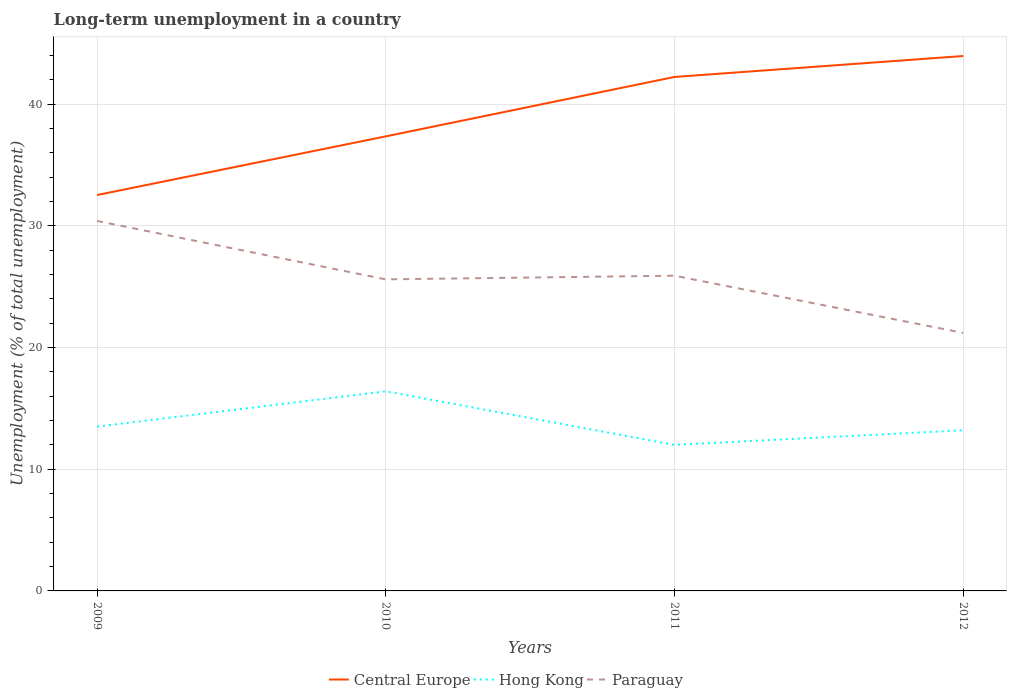Does the line corresponding to Paraguay intersect with the line corresponding to Hong Kong?
Provide a succinct answer. No. Is the number of lines equal to the number of legend labels?
Ensure brevity in your answer.  Yes. Across all years, what is the maximum percentage of long-term unemployed population in Central Europe?
Your answer should be compact. 32.53. In which year was the percentage of long-term unemployed population in Hong Kong maximum?
Keep it short and to the point. 2011. What is the total percentage of long-term unemployed population in Hong Kong in the graph?
Your answer should be compact. 3.2. What is the difference between the highest and the second highest percentage of long-term unemployed population in Central Europe?
Your answer should be compact. 11.42. Is the percentage of long-term unemployed population in Hong Kong strictly greater than the percentage of long-term unemployed population in Central Europe over the years?
Your answer should be compact. Yes. What is the difference between two consecutive major ticks on the Y-axis?
Offer a very short reply. 10. Are the values on the major ticks of Y-axis written in scientific E-notation?
Keep it short and to the point. No. Does the graph contain grids?
Give a very brief answer. Yes. What is the title of the graph?
Provide a succinct answer. Long-term unemployment in a country. What is the label or title of the X-axis?
Provide a succinct answer. Years. What is the label or title of the Y-axis?
Your answer should be compact. Unemployment (% of total unemployment). What is the Unemployment (% of total unemployment) of Central Europe in 2009?
Give a very brief answer. 32.53. What is the Unemployment (% of total unemployment) in Paraguay in 2009?
Your response must be concise. 30.4. What is the Unemployment (% of total unemployment) of Central Europe in 2010?
Offer a terse response. 37.35. What is the Unemployment (% of total unemployment) in Hong Kong in 2010?
Give a very brief answer. 16.4. What is the Unemployment (% of total unemployment) in Paraguay in 2010?
Your answer should be very brief. 25.6. What is the Unemployment (% of total unemployment) of Central Europe in 2011?
Your answer should be compact. 42.23. What is the Unemployment (% of total unemployment) of Paraguay in 2011?
Ensure brevity in your answer.  25.9. What is the Unemployment (% of total unemployment) in Central Europe in 2012?
Offer a terse response. 43.95. What is the Unemployment (% of total unemployment) of Hong Kong in 2012?
Offer a very short reply. 13.2. What is the Unemployment (% of total unemployment) in Paraguay in 2012?
Offer a very short reply. 21.2. Across all years, what is the maximum Unemployment (% of total unemployment) of Central Europe?
Your answer should be very brief. 43.95. Across all years, what is the maximum Unemployment (% of total unemployment) of Hong Kong?
Provide a short and direct response. 16.4. Across all years, what is the maximum Unemployment (% of total unemployment) of Paraguay?
Your answer should be compact. 30.4. Across all years, what is the minimum Unemployment (% of total unemployment) of Central Europe?
Keep it short and to the point. 32.53. Across all years, what is the minimum Unemployment (% of total unemployment) of Hong Kong?
Give a very brief answer. 12. Across all years, what is the minimum Unemployment (% of total unemployment) of Paraguay?
Provide a short and direct response. 21.2. What is the total Unemployment (% of total unemployment) in Central Europe in the graph?
Your response must be concise. 156.06. What is the total Unemployment (% of total unemployment) of Hong Kong in the graph?
Your answer should be very brief. 55.1. What is the total Unemployment (% of total unemployment) of Paraguay in the graph?
Your answer should be compact. 103.1. What is the difference between the Unemployment (% of total unemployment) in Central Europe in 2009 and that in 2010?
Your answer should be very brief. -4.82. What is the difference between the Unemployment (% of total unemployment) of Central Europe in 2009 and that in 2011?
Make the answer very short. -9.7. What is the difference between the Unemployment (% of total unemployment) in Hong Kong in 2009 and that in 2011?
Your answer should be compact. 1.5. What is the difference between the Unemployment (% of total unemployment) in Paraguay in 2009 and that in 2011?
Make the answer very short. 4.5. What is the difference between the Unemployment (% of total unemployment) of Central Europe in 2009 and that in 2012?
Your response must be concise. -11.42. What is the difference between the Unemployment (% of total unemployment) of Hong Kong in 2009 and that in 2012?
Provide a short and direct response. 0.3. What is the difference between the Unemployment (% of total unemployment) in Paraguay in 2009 and that in 2012?
Your answer should be very brief. 9.2. What is the difference between the Unemployment (% of total unemployment) in Central Europe in 2010 and that in 2011?
Keep it short and to the point. -4.88. What is the difference between the Unemployment (% of total unemployment) of Hong Kong in 2010 and that in 2011?
Provide a short and direct response. 4.4. What is the difference between the Unemployment (% of total unemployment) of Central Europe in 2010 and that in 2012?
Your response must be concise. -6.6. What is the difference between the Unemployment (% of total unemployment) of Central Europe in 2011 and that in 2012?
Your response must be concise. -1.72. What is the difference between the Unemployment (% of total unemployment) of Central Europe in 2009 and the Unemployment (% of total unemployment) of Hong Kong in 2010?
Provide a short and direct response. 16.13. What is the difference between the Unemployment (% of total unemployment) in Central Europe in 2009 and the Unemployment (% of total unemployment) in Paraguay in 2010?
Ensure brevity in your answer.  6.93. What is the difference between the Unemployment (% of total unemployment) in Central Europe in 2009 and the Unemployment (% of total unemployment) in Hong Kong in 2011?
Offer a very short reply. 20.53. What is the difference between the Unemployment (% of total unemployment) of Central Europe in 2009 and the Unemployment (% of total unemployment) of Paraguay in 2011?
Ensure brevity in your answer.  6.63. What is the difference between the Unemployment (% of total unemployment) of Hong Kong in 2009 and the Unemployment (% of total unemployment) of Paraguay in 2011?
Give a very brief answer. -12.4. What is the difference between the Unemployment (% of total unemployment) of Central Europe in 2009 and the Unemployment (% of total unemployment) of Hong Kong in 2012?
Provide a succinct answer. 19.33. What is the difference between the Unemployment (% of total unemployment) of Central Europe in 2009 and the Unemployment (% of total unemployment) of Paraguay in 2012?
Offer a very short reply. 11.33. What is the difference between the Unemployment (% of total unemployment) of Central Europe in 2010 and the Unemployment (% of total unemployment) of Hong Kong in 2011?
Provide a succinct answer. 25.35. What is the difference between the Unemployment (% of total unemployment) of Central Europe in 2010 and the Unemployment (% of total unemployment) of Paraguay in 2011?
Make the answer very short. 11.45. What is the difference between the Unemployment (% of total unemployment) of Central Europe in 2010 and the Unemployment (% of total unemployment) of Hong Kong in 2012?
Offer a very short reply. 24.15. What is the difference between the Unemployment (% of total unemployment) in Central Europe in 2010 and the Unemployment (% of total unemployment) in Paraguay in 2012?
Provide a short and direct response. 16.15. What is the difference between the Unemployment (% of total unemployment) in Hong Kong in 2010 and the Unemployment (% of total unemployment) in Paraguay in 2012?
Offer a very short reply. -4.8. What is the difference between the Unemployment (% of total unemployment) in Central Europe in 2011 and the Unemployment (% of total unemployment) in Hong Kong in 2012?
Provide a short and direct response. 29.03. What is the difference between the Unemployment (% of total unemployment) of Central Europe in 2011 and the Unemployment (% of total unemployment) of Paraguay in 2012?
Offer a terse response. 21.03. What is the average Unemployment (% of total unemployment) in Central Europe per year?
Provide a short and direct response. 39.01. What is the average Unemployment (% of total unemployment) in Hong Kong per year?
Offer a very short reply. 13.78. What is the average Unemployment (% of total unemployment) in Paraguay per year?
Provide a succinct answer. 25.77. In the year 2009, what is the difference between the Unemployment (% of total unemployment) of Central Europe and Unemployment (% of total unemployment) of Hong Kong?
Your response must be concise. 19.03. In the year 2009, what is the difference between the Unemployment (% of total unemployment) in Central Europe and Unemployment (% of total unemployment) in Paraguay?
Offer a terse response. 2.13. In the year 2009, what is the difference between the Unemployment (% of total unemployment) of Hong Kong and Unemployment (% of total unemployment) of Paraguay?
Your answer should be compact. -16.9. In the year 2010, what is the difference between the Unemployment (% of total unemployment) of Central Europe and Unemployment (% of total unemployment) of Hong Kong?
Provide a succinct answer. 20.95. In the year 2010, what is the difference between the Unemployment (% of total unemployment) in Central Europe and Unemployment (% of total unemployment) in Paraguay?
Keep it short and to the point. 11.75. In the year 2010, what is the difference between the Unemployment (% of total unemployment) of Hong Kong and Unemployment (% of total unemployment) of Paraguay?
Your response must be concise. -9.2. In the year 2011, what is the difference between the Unemployment (% of total unemployment) of Central Europe and Unemployment (% of total unemployment) of Hong Kong?
Your answer should be very brief. 30.23. In the year 2011, what is the difference between the Unemployment (% of total unemployment) in Central Europe and Unemployment (% of total unemployment) in Paraguay?
Make the answer very short. 16.33. In the year 2012, what is the difference between the Unemployment (% of total unemployment) of Central Europe and Unemployment (% of total unemployment) of Hong Kong?
Make the answer very short. 30.75. In the year 2012, what is the difference between the Unemployment (% of total unemployment) of Central Europe and Unemployment (% of total unemployment) of Paraguay?
Make the answer very short. 22.75. What is the ratio of the Unemployment (% of total unemployment) in Central Europe in 2009 to that in 2010?
Provide a succinct answer. 0.87. What is the ratio of the Unemployment (% of total unemployment) of Hong Kong in 2009 to that in 2010?
Offer a terse response. 0.82. What is the ratio of the Unemployment (% of total unemployment) of Paraguay in 2009 to that in 2010?
Provide a succinct answer. 1.19. What is the ratio of the Unemployment (% of total unemployment) of Central Europe in 2009 to that in 2011?
Make the answer very short. 0.77. What is the ratio of the Unemployment (% of total unemployment) of Paraguay in 2009 to that in 2011?
Offer a terse response. 1.17. What is the ratio of the Unemployment (% of total unemployment) in Central Europe in 2009 to that in 2012?
Give a very brief answer. 0.74. What is the ratio of the Unemployment (% of total unemployment) in Hong Kong in 2009 to that in 2012?
Your answer should be compact. 1.02. What is the ratio of the Unemployment (% of total unemployment) in Paraguay in 2009 to that in 2012?
Offer a terse response. 1.43. What is the ratio of the Unemployment (% of total unemployment) of Central Europe in 2010 to that in 2011?
Provide a succinct answer. 0.88. What is the ratio of the Unemployment (% of total unemployment) in Hong Kong in 2010 to that in 2011?
Offer a terse response. 1.37. What is the ratio of the Unemployment (% of total unemployment) of Paraguay in 2010 to that in 2011?
Your response must be concise. 0.99. What is the ratio of the Unemployment (% of total unemployment) of Central Europe in 2010 to that in 2012?
Your answer should be very brief. 0.85. What is the ratio of the Unemployment (% of total unemployment) of Hong Kong in 2010 to that in 2012?
Offer a very short reply. 1.24. What is the ratio of the Unemployment (% of total unemployment) in Paraguay in 2010 to that in 2012?
Keep it short and to the point. 1.21. What is the ratio of the Unemployment (% of total unemployment) of Central Europe in 2011 to that in 2012?
Ensure brevity in your answer.  0.96. What is the ratio of the Unemployment (% of total unemployment) of Paraguay in 2011 to that in 2012?
Give a very brief answer. 1.22. What is the difference between the highest and the second highest Unemployment (% of total unemployment) of Central Europe?
Ensure brevity in your answer.  1.72. What is the difference between the highest and the second highest Unemployment (% of total unemployment) in Hong Kong?
Make the answer very short. 2.9. What is the difference between the highest and the second highest Unemployment (% of total unemployment) of Paraguay?
Ensure brevity in your answer.  4.5. What is the difference between the highest and the lowest Unemployment (% of total unemployment) of Central Europe?
Give a very brief answer. 11.42. 